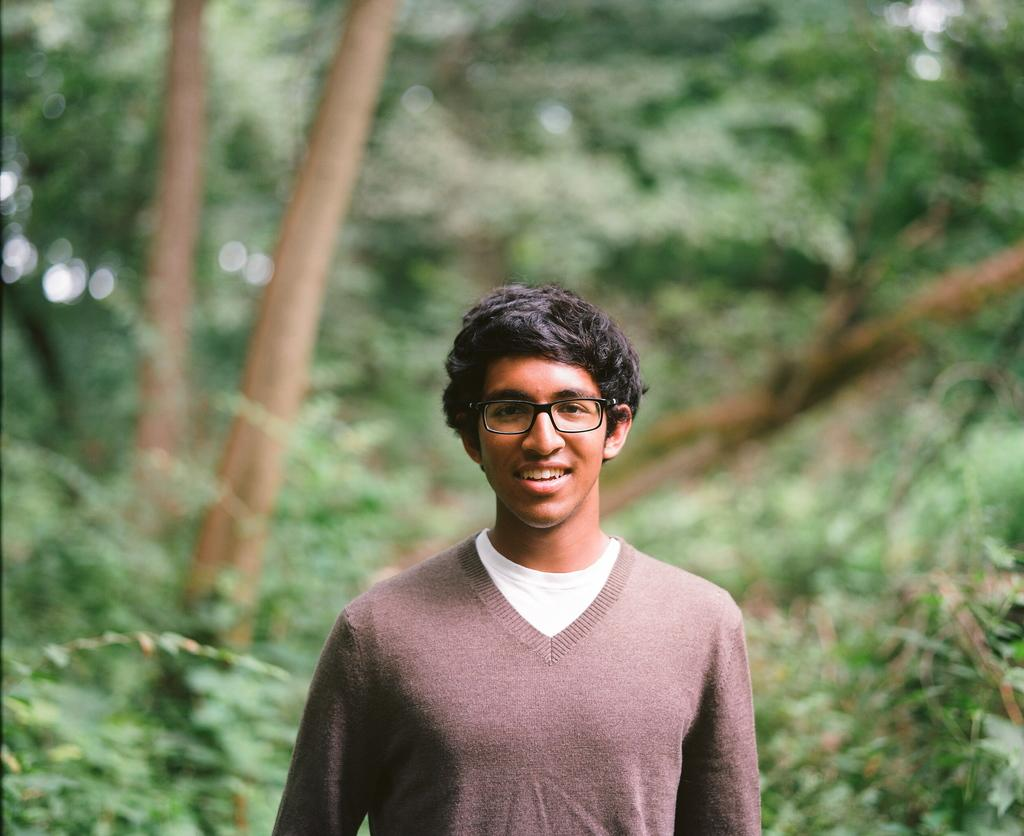Who or what is the main subject of the image? There is a person in the image. What is the person doing in the image? The person is posing for the camera. What expression does the person have on their face? The person has a smile on their face. What can be seen in the background of the image? There are trees visible in the background of the image. What type of question is being asked in the image? There is no question being asked in the image; it is a person posing for the camera with a smile on their face. What business is being conducted in the image? There is no business being conducted in the image; it is a person posing for the camera with a smile on their face. 